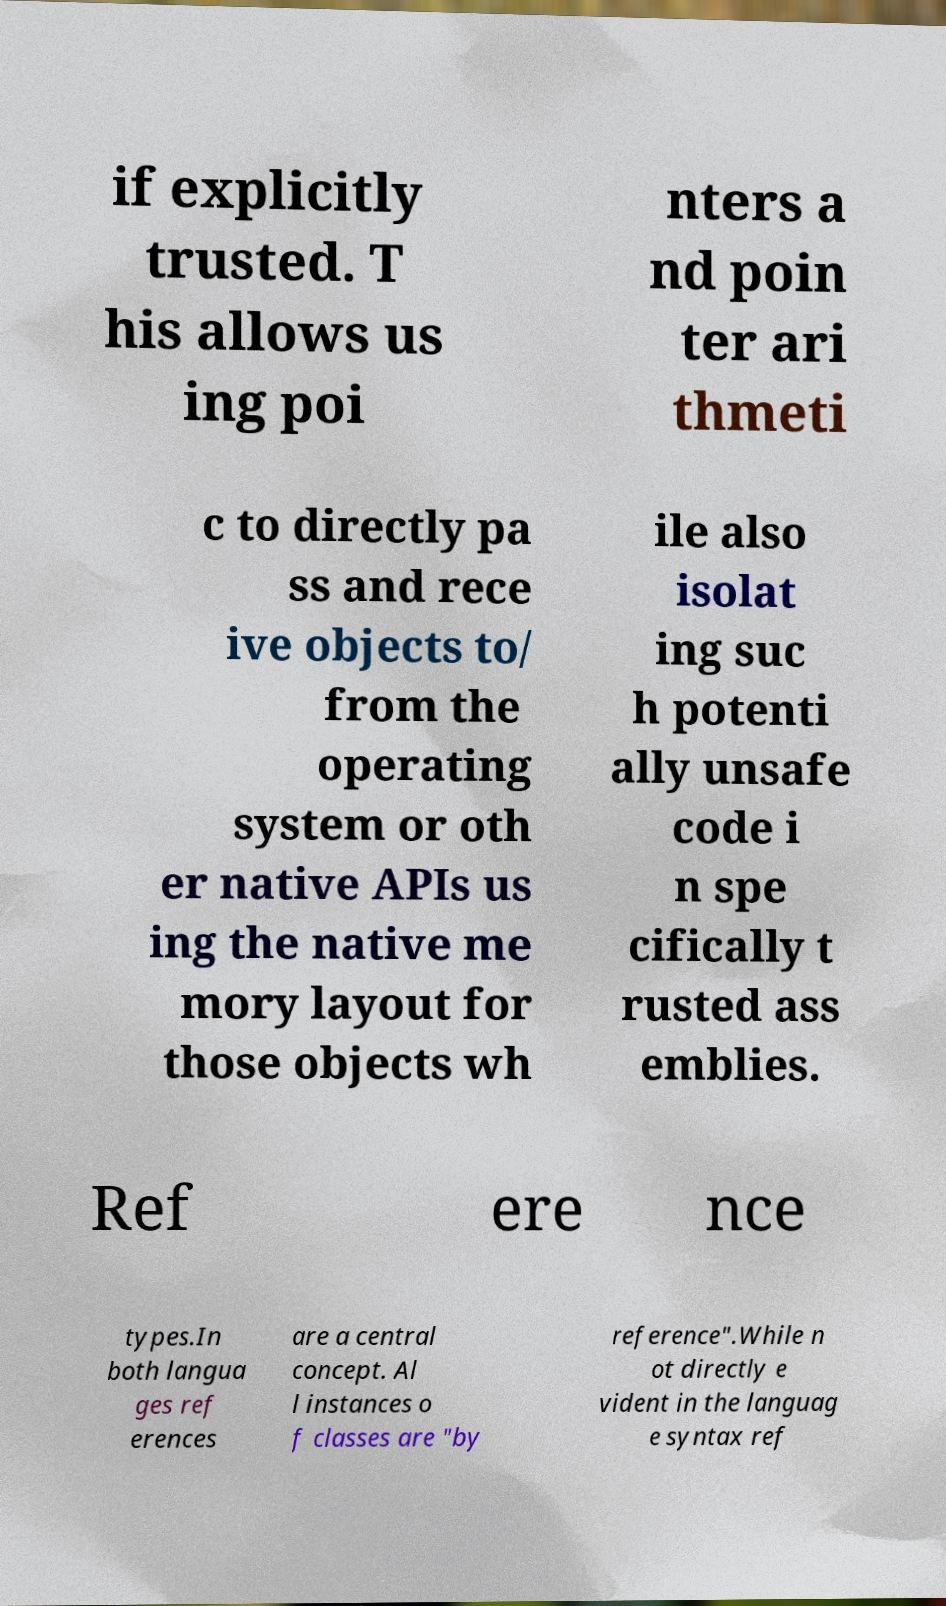There's text embedded in this image that I need extracted. Can you transcribe it verbatim? if explicitly trusted. T his allows us ing poi nters a nd poin ter ari thmeti c to directly pa ss and rece ive objects to/ from the operating system or oth er native APIs us ing the native me mory layout for those objects wh ile also isolat ing suc h potenti ally unsafe code i n spe cifically t rusted ass emblies. Ref ere nce types.In both langua ges ref erences are a central concept. Al l instances o f classes are "by reference".While n ot directly e vident in the languag e syntax ref 